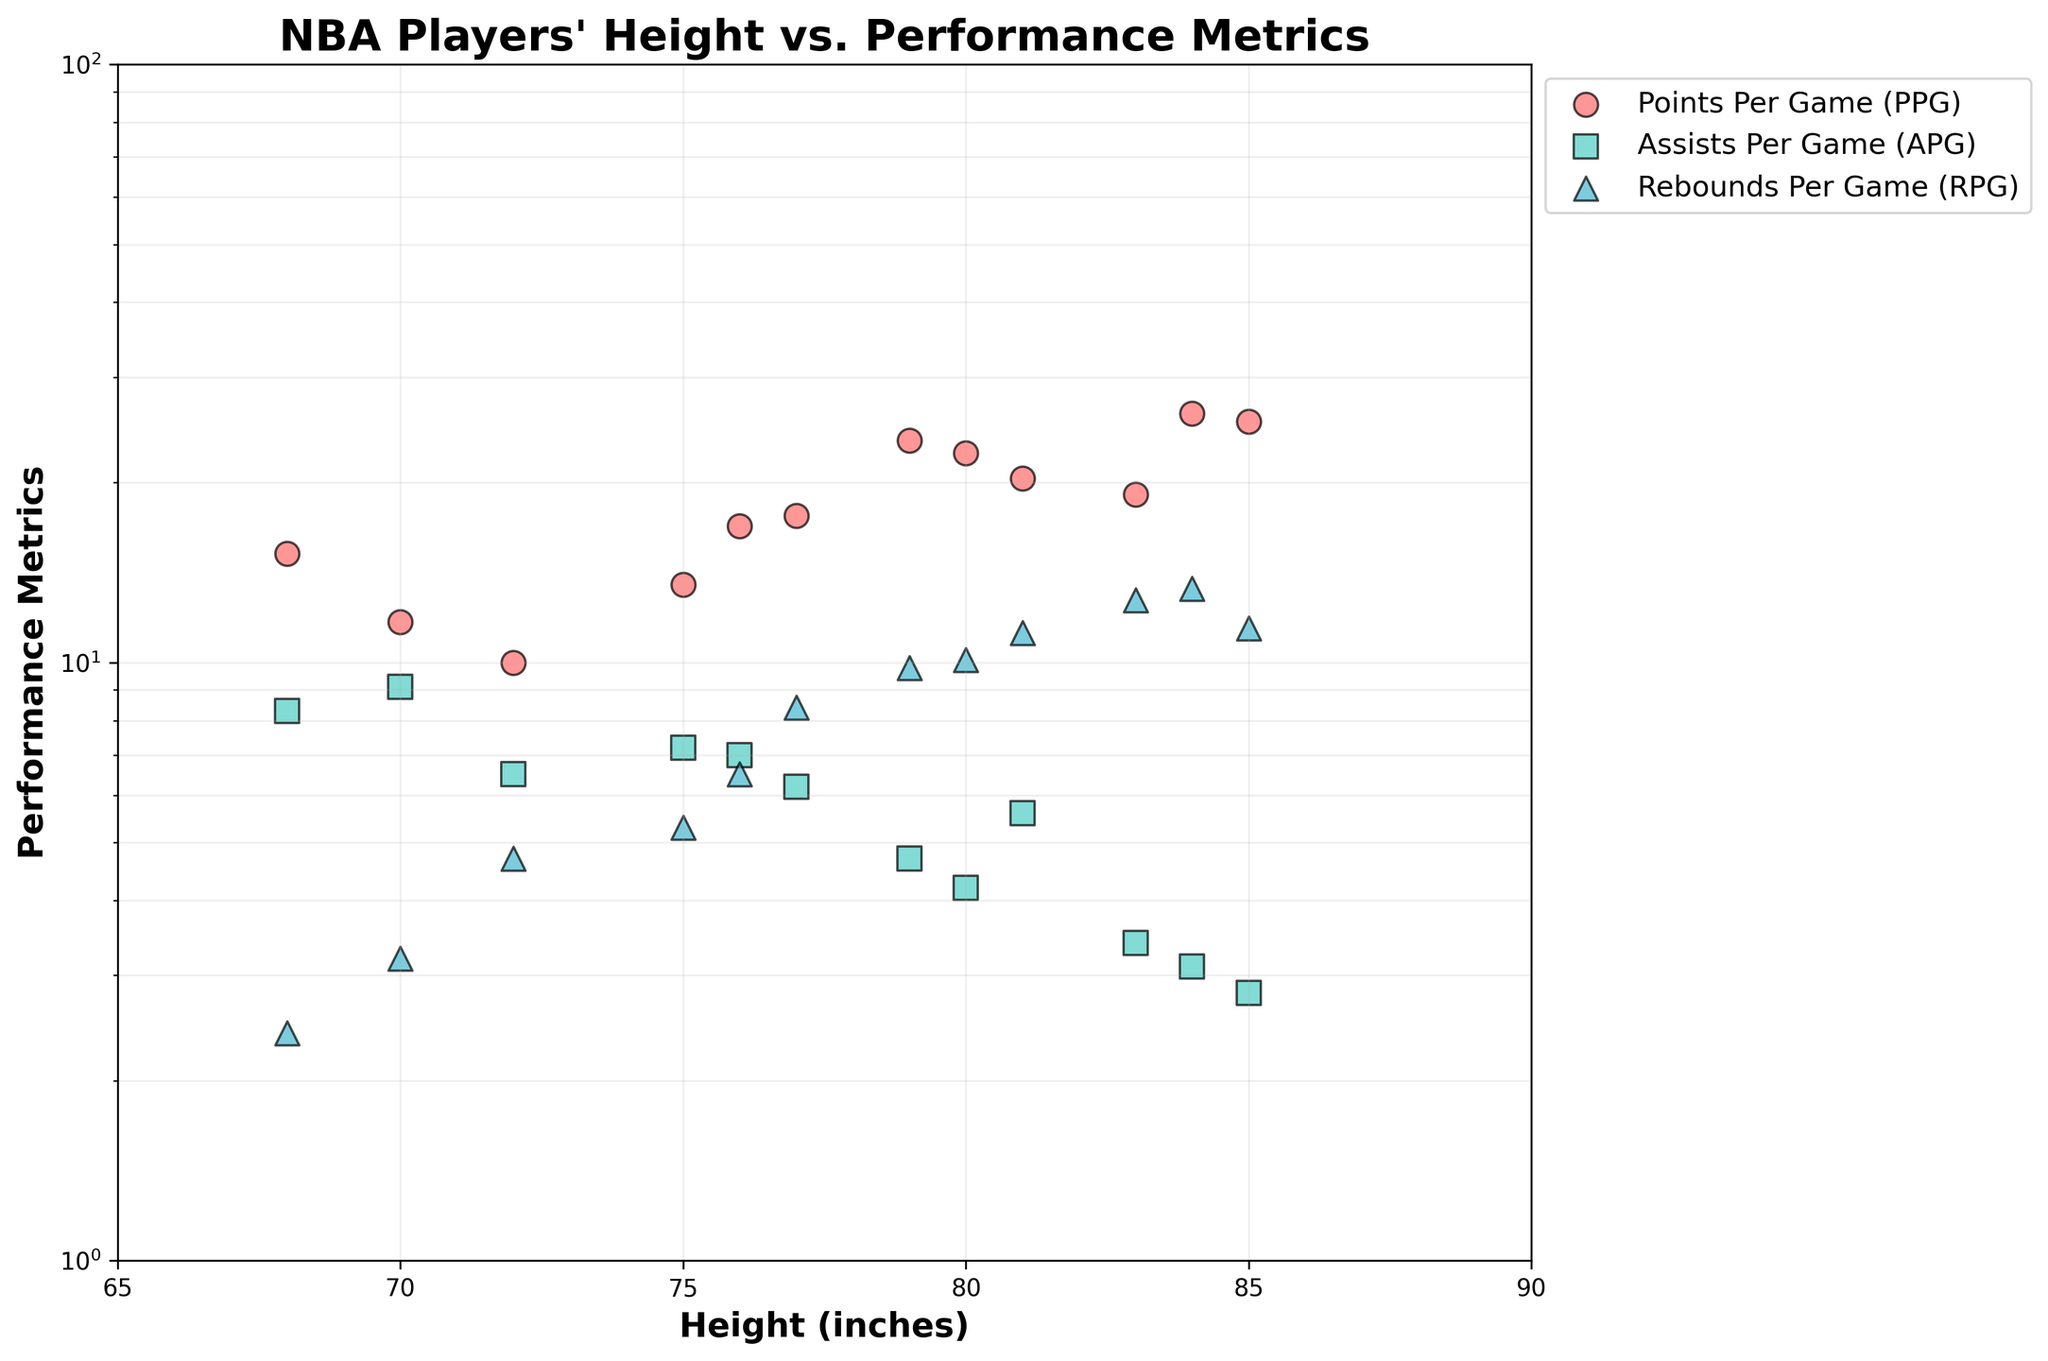What is the title of the plot? The title is displayed at the top of the plot and briefly describes the content being presented.
Answer: NBA Players' Height vs. Performance Metrics What are the unique performance metrics shown in the plot? There are three distinct performance metrics, each plotted in different colors and markers.
Answer: Points Per Game (PPG), Assists Per Game (APG), Rebounds Per Game (RPG) Which height range do the data points fall within? The x-axis represents height in inches and the range shows the minimum and maximum values displayed.
Answer: 68 to 85 inches How many data points are included in the plot? By counting each individual data point represented as a marker on the plot, it is clear how many total data points there are.
Answer: 12 What does the y-axis represent and how is it scaled? The y-axis shows the performance metrics, and the scaling type is indicated by the logarithmic labels.
Answer: Performance metrics in log scale What is the PPG for the tallest player in the dataset? The highest point on the x-axis represents the tallest player, and the corresponding y-value gives the performance metric for PPG.
Answer: 26.1 Which player height has the highest Points Per Game (PPG)? Locate the peak value on the y-axis for PPG and find its corresponding x-axis value representing the player's height.
Answer: 84 inches What trend can be observed between player height and Points Per Game (PPG)? By looking at data points along the x-axis and their corresponding y-values, infer patterns or trends in the relationship.
Answer: Higher heights generally correspond with higher PPG 